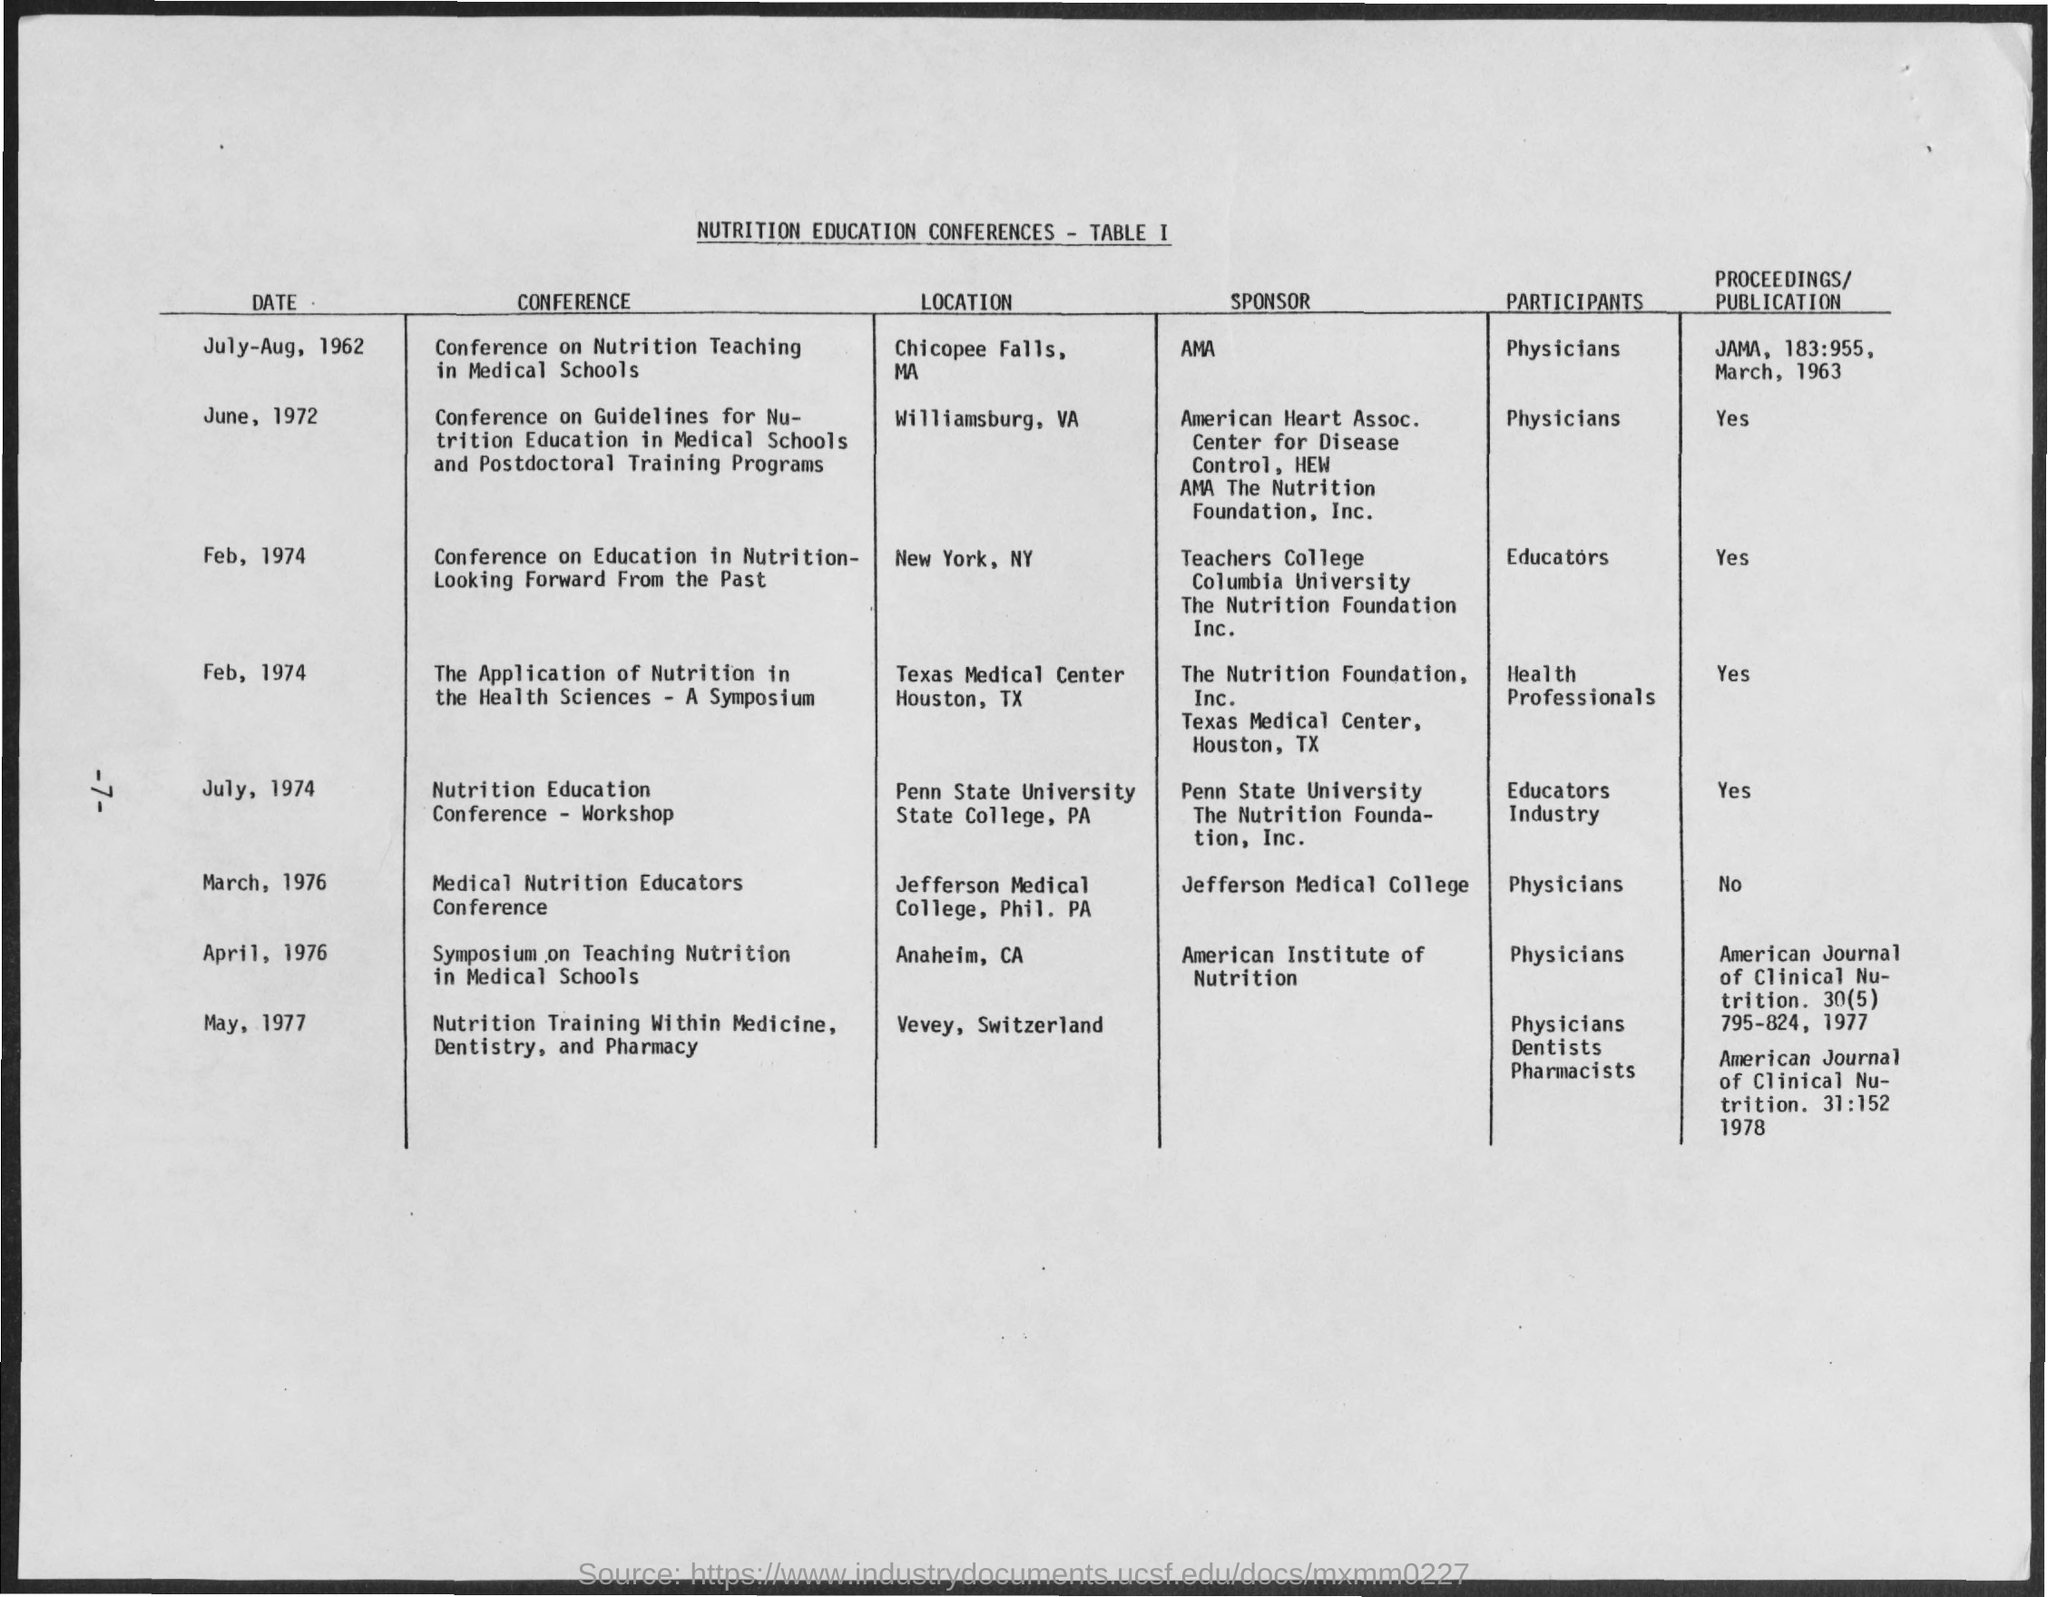Give some essential details in this illustration. The date for the Nutrition Education Conference - Workshop is July 1974. The publication for the Conference on Nutrition Teaching in Medical Schools was "What is the Proceedings/Publication for Conference on Nutrition Teaching in Medical Schools? JAMA, 183:955, March, 1963. The participants for the Nutrition Education Conference - Workshop are educators. The American Medical Association (AMA) is the sponsor for the Conference on Nutrition Teaching in Medical Schools. The Conference on Nutrition Teaching in Medical Schools will take place from July to August, 1962. 